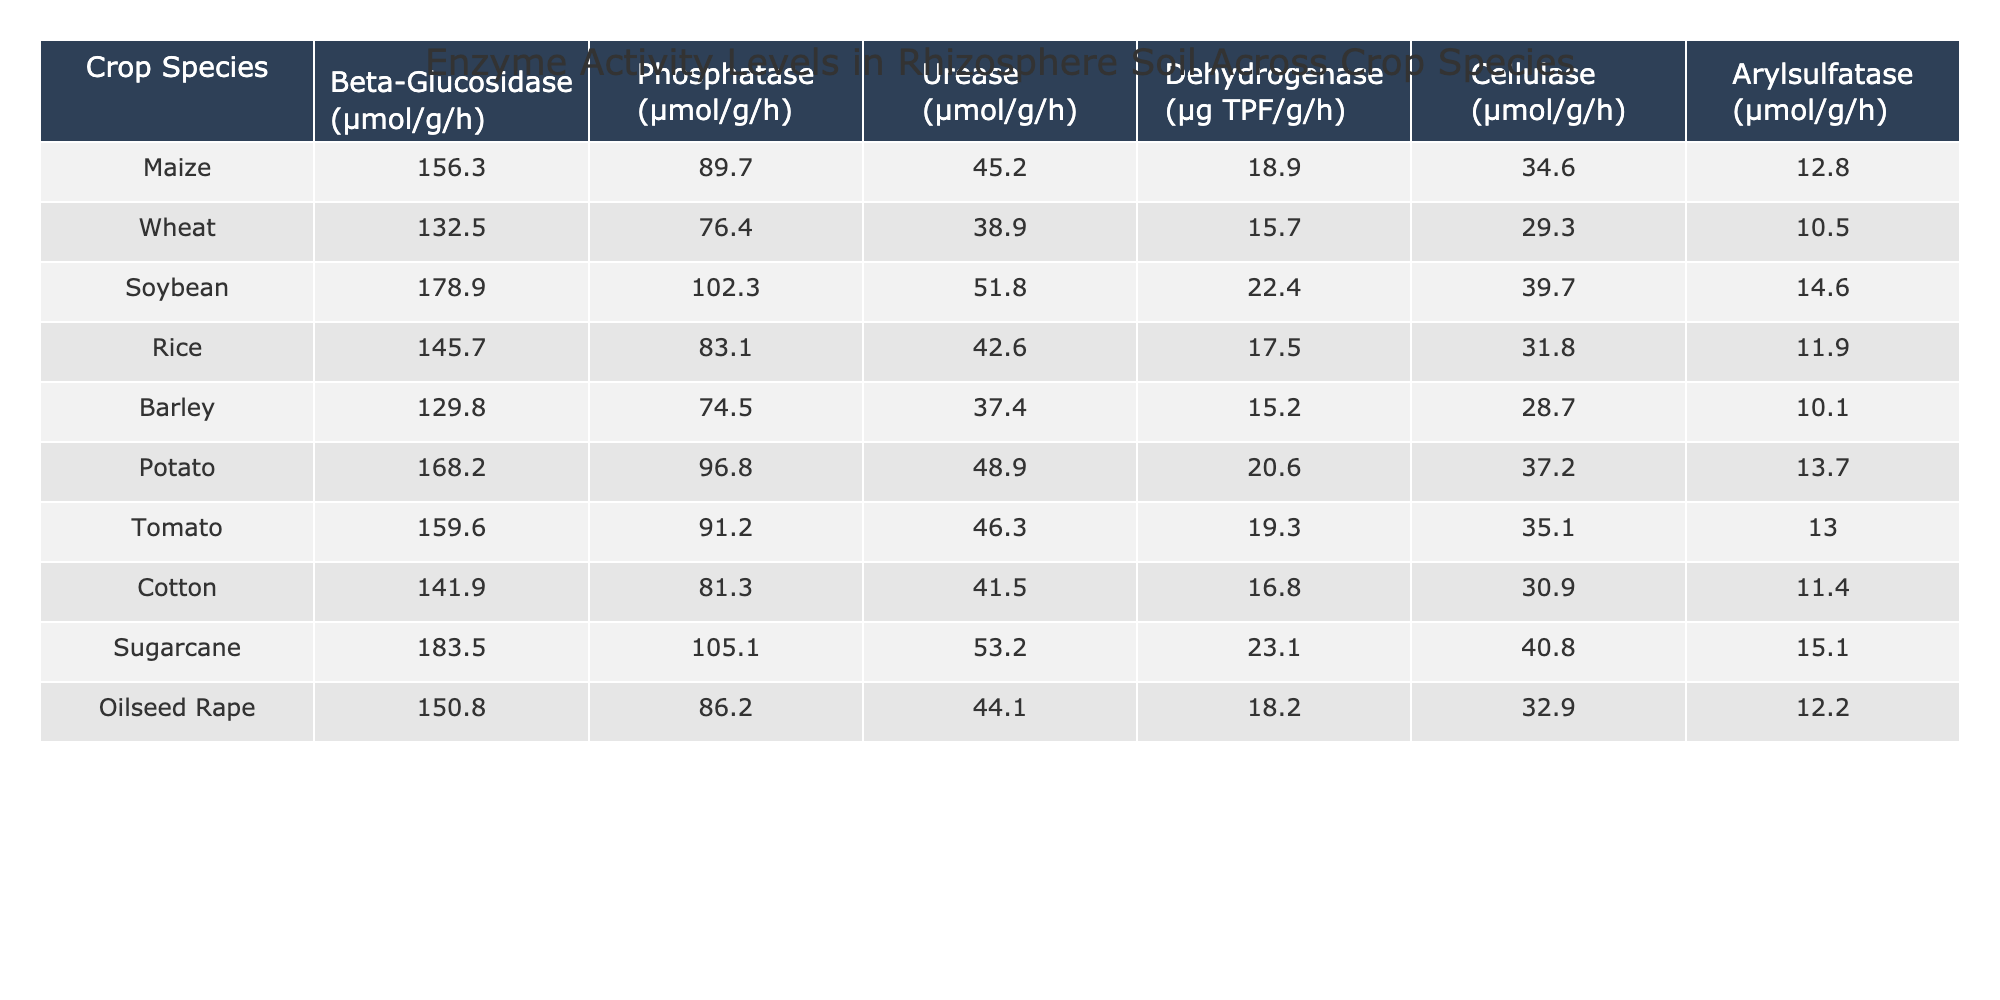What is the enzyme activity level of Beta-Glucosidase in Sugarcane? The table lists Sugarcane under Crop Species, and the corresponding Beta-Glucosidase activity level is 183.5 μmol/g/h.
Answer: 183.5 μmol/g/h Which crop species has the highest Urease activity level? By reviewing the Urease activity column, Sugarcane has the highest level at 53.2 μmol/g/h, compared to other species.
Answer: Sugarcane What is the average Phosphatase activity level across the crops? Adding the Phosphatase values (89.7 + 76.4 + 102.3 + 83.1 + 74.5 + 96.8 + 91.2 + 81.3 + 105.1 + 86.2) equals 905. The total number of species is 10, so the average is 905/10 = 90.5.
Answer: 90.5 μmol/g/h Is the Urease activity level in Soybean greater than that in Wheat? The Urease level for Soybean is 51.8 μmol/g/h and for Wheat is 38.9 μmol/g/h. Since 51.8 is greater than 38.9, the statement is true.
Answer: Yes What is the difference in Dehydrogenase activity between Maize and Cotton? Dehydrogenase activity for Maize is 18.9 μg TPF/g/h and for Cotton it is 16.8 μg TPF/g/h. The difference is calculated as 18.9 - 16.8 = 2.1.
Answer: 2.1 μg TPF/g/h Which crop has the lowest Arylsulfatase activity? Reviewing the Arylsulfatase values, Barley has the lowest at 10.1 μmol/g/h when compared to all other crops listed.
Answer: Barley If we consider the top three crops for Cellulase activity, what is their average? The top three crops based on Cellulase values are Sugarcane (40.8), Soybean (39.7), and Potato (37.2). Their total is 40.8 + 39.7 + 37.2 = 117.7. The average is thus 117.7 / 3 = 39.23.
Answer: 39.23 μmol/g/h Does Rice have the highest Beta-Glucosidase activity among the crops listed? Comparing the Beta-Glucosidase levels, Rice has 145.7 μmol/g/h, which is lower than Soybean (178.9 μmol/g/h) and Sugarcane (183.5 μmol/g/h). Thus, Rice does not have the highest activity.
Answer: No What is the sum of Phosphatase activities for Maize, Potato, and Tomato? Adding the Phosphatase activities of Maize (89.7), Potato (96.8), and Tomato (91.2) gives 89.7 + 96.8 + 91.2 = 277.7.
Answer: 277.7 μmol/g/h Which crop species has the closest Urease activity level to that of Wheat? Checking the Urease values, Wheat has 38.9 μmol/g/h, and the closest levels are Barley with 37.4 and Cotton with 41.5, making Barley the closest.
Answer: Barley 